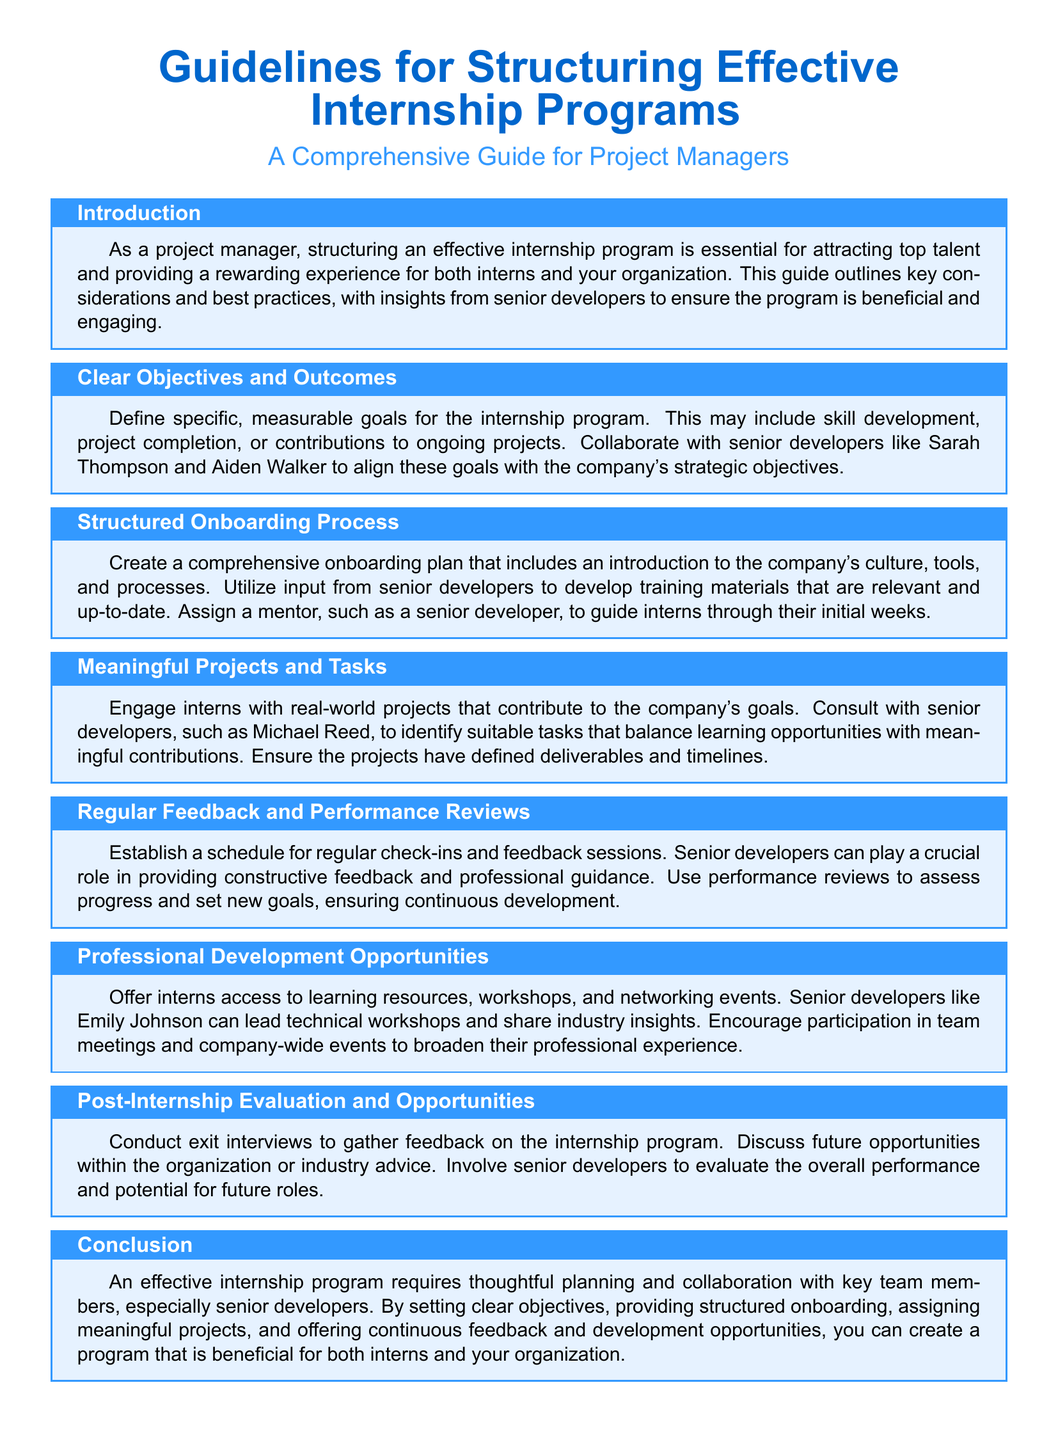What is the title of the guide? The title is prominently displayed at the top of the document, stating its purpose and audience.
Answer: Guidelines for Structuring Effective Internship Programs Who is the intended audience for the guide? The guide specifies that it is aimed at a particular group interested in structuring internship programs.
Answer: Project Managers What is the first section of the guide called? The sections are labeled to indicate the content focus, with the first being an introduction.
Answer: Introduction What is one key role of senior developers in the internship program? The document outlines multiple tasks and responsibilities of senior developers in supporting the program.
Answer: Providing feedback What type of opportunities should be offered to interns? The guide emphasizes the importance of providing specific resources to enhance interns' experiences.
Answer: Professional Development Opportunities What is a recommended action during the post-internship phase? This section highlights the necessity of feedback mechanisms to assess the program's effectiveness.
Answer: Conduct exit interviews How should meaningful projects be identified? The document suggests a collaborative approach when determining project tasks for interns.
Answer: Consult with senior developers What is emphasized throughout the guide for effective internship structuring? The guide repeatedly highlights a particular theme related to organization and planning.
Answer: Collaboration 